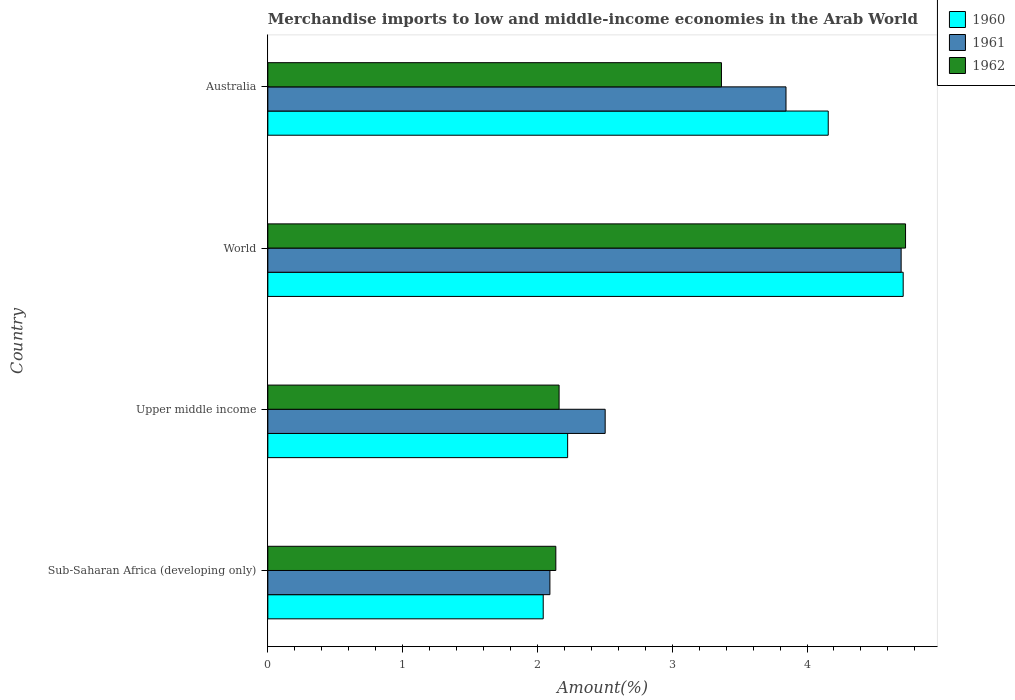How many groups of bars are there?
Your answer should be compact. 4. Are the number of bars per tick equal to the number of legend labels?
Give a very brief answer. Yes. How many bars are there on the 1st tick from the top?
Your response must be concise. 3. What is the label of the 1st group of bars from the top?
Offer a terse response. Australia. What is the percentage of amount earned from merchandise imports in 1962 in Upper middle income?
Your answer should be very brief. 2.16. Across all countries, what is the maximum percentage of amount earned from merchandise imports in 1961?
Your response must be concise. 4.7. Across all countries, what is the minimum percentage of amount earned from merchandise imports in 1961?
Make the answer very short. 2.09. In which country was the percentage of amount earned from merchandise imports in 1960 maximum?
Your answer should be compact. World. In which country was the percentage of amount earned from merchandise imports in 1962 minimum?
Offer a terse response. Sub-Saharan Africa (developing only). What is the total percentage of amount earned from merchandise imports in 1961 in the graph?
Offer a terse response. 13.14. What is the difference between the percentage of amount earned from merchandise imports in 1961 in Upper middle income and that in World?
Your response must be concise. -2.2. What is the difference between the percentage of amount earned from merchandise imports in 1960 in Upper middle income and the percentage of amount earned from merchandise imports in 1961 in Australia?
Keep it short and to the point. -1.62. What is the average percentage of amount earned from merchandise imports in 1962 per country?
Keep it short and to the point. 3.1. What is the difference between the percentage of amount earned from merchandise imports in 1961 and percentage of amount earned from merchandise imports in 1960 in World?
Offer a terse response. -0.02. What is the ratio of the percentage of amount earned from merchandise imports in 1960 in Upper middle income to that in World?
Keep it short and to the point. 0.47. Is the difference between the percentage of amount earned from merchandise imports in 1961 in Australia and World greater than the difference between the percentage of amount earned from merchandise imports in 1960 in Australia and World?
Keep it short and to the point. No. What is the difference between the highest and the second highest percentage of amount earned from merchandise imports in 1961?
Ensure brevity in your answer.  0.85. What is the difference between the highest and the lowest percentage of amount earned from merchandise imports in 1962?
Your answer should be compact. 2.59. Is the sum of the percentage of amount earned from merchandise imports in 1961 in Sub-Saharan Africa (developing only) and Upper middle income greater than the maximum percentage of amount earned from merchandise imports in 1960 across all countries?
Offer a very short reply. No. What does the 2nd bar from the bottom in Upper middle income represents?
Provide a short and direct response. 1961. How many bars are there?
Ensure brevity in your answer.  12. Are all the bars in the graph horizontal?
Give a very brief answer. Yes. How many countries are there in the graph?
Give a very brief answer. 4. Does the graph contain grids?
Keep it short and to the point. No. Where does the legend appear in the graph?
Keep it short and to the point. Top right. What is the title of the graph?
Offer a terse response. Merchandise imports to low and middle-income economies in the Arab World. What is the label or title of the X-axis?
Your answer should be very brief. Amount(%). What is the label or title of the Y-axis?
Provide a succinct answer. Country. What is the Amount(%) in 1960 in Sub-Saharan Africa (developing only)?
Your answer should be very brief. 2.04. What is the Amount(%) in 1961 in Sub-Saharan Africa (developing only)?
Provide a succinct answer. 2.09. What is the Amount(%) of 1962 in Sub-Saharan Africa (developing only)?
Provide a succinct answer. 2.14. What is the Amount(%) in 1960 in Upper middle income?
Your answer should be very brief. 2.22. What is the Amount(%) in 1961 in Upper middle income?
Your response must be concise. 2.5. What is the Amount(%) in 1962 in Upper middle income?
Offer a very short reply. 2.16. What is the Amount(%) in 1960 in World?
Provide a short and direct response. 4.71. What is the Amount(%) in 1961 in World?
Your answer should be compact. 4.7. What is the Amount(%) of 1962 in World?
Offer a very short reply. 4.73. What is the Amount(%) of 1960 in Australia?
Provide a succinct answer. 4.16. What is the Amount(%) in 1961 in Australia?
Make the answer very short. 3.84. What is the Amount(%) of 1962 in Australia?
Provide a succinct answer. 3.37. Across all countries, what is the maximum Amount(%) in 1960?
Your answer should be compact. 4.71. Across all countries, what is the maximum Amount(%) in 1961?
Offer a terse response. 4.7. Across all countries, what is the maximum Amount(%) in 1962?
Your response must be concise. 4.73. Across all countries, what is the minimum Amount(%) of 1960?
Your answer should be very brief. 2.04. Across all countries, what is the minimum Amount(%) of 1961?
Ensure brevity in your answer.  2.09. Across all countries, what is the minimum Amount(%) of 1962?
Provide a short and direct response. 2.14. What is the total Amount(%) in 1960 in the graph?
Keep it short and to the point. 13.14. What is the total Amount(%) of 1961 in the graph?
Ensure brevity in your answer.  13.14. What is the total Amount(%) in 1962 in the graph?
Your answer should be very brief. 12.39. What is the difference between the Amount(%) of 1960 in Sub-Saharan Africa (developing only) and that in Upper middle income?
Your response must be concise. -0.18. What is the difference between the Amount(%) of 1961 in Sub-Saharan Africa (developing only) and that in Upper middle income?
Offer a very short reply. -0.41. What is the difference between the Amount(%) of 1962 in Sub-Saharan Africa (developing only) and that in Upper middle income?
Your answer should be compact. -0.02. What is the difference between the Amount(%) of 1960 in Sub-Saharan Africa (developing only) and that in World?
Keep it short and to the point. -2.67. What is the difference between the Amount(%) of 1961 in Sub-Saharan Africa (developing only) and that in World?
Give a very brief answer. -2.61. What is the difference between the Amount(%) in 1962 in Sub-Saharan Africa (developing only) and that in World?
Your answer should be very brief. -2.59. What is the difference between the Amount(%) in 1960 in Sub-Saharan Africa (developing only) and that in Australia?
Offer a terse response. -2.11. What is the difference between the Amount(%) in 1961 in Sub-Saharan Africa (developing only) and that in Australia?
Keep it short and to the point. -1.75. What is the difference between the Amount(%) of 1962 in Sub-Saharan Africa (developing only) and that in Australia?
Ensure brevity in your answer.  -1.23. What is the difference between the Amount(%) in 1960 in Upper middle income and that in World?
Offer a very short reply. -2.49. What is the difference between the Amount(%) in 1961 in Upper middle income and that in World?
Make the answer very short. -2.2. What is the difference between the Amount(%) in 1962 in Upper middle income and that in World?
Provide a succinct answer. -2.57. What is the difference between the Amount(%) in 1960 in Upper middle income and that in Australia?
Give a very brief answer. -1.93. What is the difference between the Amount(%) in 1961 in Upper middle income and that in Australia?
Your answer should be compact. -1.34. What is the difference between the Amount(%) in 1962 in Upper middle income and that in Australia?
Make the answer very short. -1.2. What is the difference between the Amount(%) in 1960 in World and that in Australia?
Ensure brevity in your answer.  0.56. What is the difference between the Amount(%) in 1961 in World and that in Australia?
Offer a very short reply. 0.85. What is the difference between the Amount(%) of 1962 in World and that in Australia?
Offer a terse response. 1.37. What is the difference between the Amount(%) in 1960 in Sub-Saharan Africa (developing only) and the Amount(%) in 1961 in Upper middle income?
Your response must be concise. -0.46. What is the difference between the Amount(%) in 1960 in Sub-Saharan Africa (developing only) and the Amount(%) in 1962 in Upper middle income?
Provide a short and direct response. -0.12. What is the difference between the Amount(%) in 1961 in Sub-Saharan Africa (developing only) and the Amount(%) in 1962 in Upper middle income?
Offer a terse response. -0.07. What is the difference between the Amount(%) of 1960 in Sub-Saharan Africa (developing only) and the Amount(%) of 1961 in World?
Offer a very short reply. -2.66. What is the difference between the Amount(%) in 1960 in Sub-Saharan Africa (developing only) and the Amount(%) in 1962 in World?
Your answer should be compact. -2.69. What is the difference between the Amount(%) of 1961 in Sub-Saharan Africa (developing only) and the Amount(%) of 1962 in World?
Provide a short and direct response. -2.64. What is the difference between the Amount(%) of 1960 in Sub-Saharan Africa (developing only) and the Amount(%) of 1961 in Australia?
Make the answer very short. -1.8. What is the difference between the Amount(%) in 1960 in Sub-Saharan Africa (developing only) and the Amount(%) in 1962 in Australia?
Your answer should be very brief. -1.32. What is the difference between the Amount(%) in 1961 in Sub-Saharan Africa (developing only) and the Amount(%) in 1962 in Australia?
Make the answer very short. -1.27. What is the difference between the Amount(%) of 1960 in Upper middle income and the Amount(%) of 1961 in World?
Provide a short and direct response. -2.47. What is the difference between the Amount(%) of 1960 in Upper middle income and the Amount(%) of 1962 in World?
Ensure brevity in your answer.  -2.51. What is the difference between the Amount(%) in 1961 in Upper middle income and the Amount(%) in 1962 in World?
Keep it short and to the point. -2.23. What is the difference between the Amount(%) of 1960 in Upper middle income and the Amount(%) of 1961 in Australia?
Give a very brief answer. -1.62. What is the difference between the Amount(%) in 1960 in Upper middle income and the Amount(%) in 1962 in Australia?
Give a very brief answer. -1.14. What is the difference between the Amount(%) in 1961 in Upper middle income and the Amount(%) in 1962 in Australia?
Keep it short and to the point. -0.86. What is the difference between the Amount(%) of 1960 in World and the Amount(%) of 1961 in Australia?
Offer a terse response. 0.87. What is the difference between the Amount(%) in 1960 in World and the Amount(%) in 1962 in Australia?
Your answer should be very brief. 1.35. What is the difference between the Amount(%) of 1961 in World and the Amount(%) of 1962 in Australia?
Ensure brevity in your answer.  1.33. What is the average Amount(%) in 1960 per country?
Provide a short and direct response. 3.28. What is the average Amount(%) of 1961 per country?
Make the answer very short. 3.28. What is the average Amount(%) in 1962 per country?
Ensure brevity in your answer.  3.1. What is the difference between the Amount(%) in 1960 and Amount(%) in 1961 in Sub-Saharan Africa (developing only)?
Give a very brief answer. -0.05. What is the difference between the Amount(%) in 1960 and Amount(%) in 1962 in Sub-Saharan Africa (developing only)?
Offer a terse response. -0.09. What is the difference between the Amount(%) of 1961 and Amount(%) of 1962 in Sub-Saharan Africa (developing only)?
Give a very brief answer. -0.04. What is the difference between the Amount(%) in 1960 and Amount(%) in 1961 in Upper middle income?
Provide a succinct answer. -0.28. What is the difference between the Amount(%) in 1960 and Amount(%) in 1962 in Upper middle income?
Your answer should be very brief. 0.06. What is the difference between the Amount(%) in 1961 and Amount(%) in 1962 in Upper middle income?
Your answer should be compact. 0.34. What is the difference between the Amount(%) in 1960 and Amount(%) in 1961 in World?
Keep it short and to the point. 0.02. What is the difference between the Amount(%) in 1960 and Amount(%) in 1962 in World?
Your answer should be compact. -0.02. What is the difference between the Amount(%) in 1961 and Amount(%) in 1962 in World?
Give a very brief answer. -0.03. What is the difference between the Amount(%) of 1960 and Amount(%) of 1961 in Australia?
Give a very brief answer. 0.31. What is the difference between the Amount(%) in 1960 and Amount(%) in 1962 in Australia?
Offer a very short reply. 0.79. What is the difference between the Amount(%) in 1961 and Amount(%) in 1962 in Australia?
Provide a short and direct response. 0.48. What is the ratio of the Amount(%) of 1960 in Sub-Saharan Africa (developing only) to that in Upper middle income?
Make the answer very short. 0.92. What is the ratio of the Amount(%) of 1961 in Sub-Saharan Africa (developing only) to that in Upper middle income?
Provide a succinct answer. 0.84. What is the ratio of the Amount(%) in 1962 in Sub-Saharan Africa (developing only) to that in Upper middle income?
Provide a succinct answer. 0.99. What is the ratio of the Amount(%) in 1960 in Sub-Saharan Africa (developing only) to that in World?
Your response must be concise. 0.43. What is the ratio of the Amount(%) of 1961 in Sub-Saharan Africa (developing only) to that in World?
Your answer should be compact. 0.45. What is the ratio of the Amount(%) in 1962 in Sub-Saharan Africa (developing only) to that in World?
Make the answer very short. 0.45. What is the ratio of the Amount(%) in 1960 in Sub-Saharan Africa (developing only) to that in Australia?
Offer a terse response. 0.49. What is the ratio of the Amount(%) in 1961 in Sub-Saharan Africa (developing only) to that in Australia?
Your answer should be compact. 0.54. What is the ratio of the Amount(%) of 1962 in Sub-Saharan Africa (developing only) to that in Australia?
Make the answer very short. 0.63. What is the ratio of the Amount(%) in 1960 in Upper middle income to that in World?
Your answer should be compact. 0.47. What is the ratio of the Amount(%) of 1961 in Upper middle income to that in World?
Your answer should be very brief. 0.53. What is the ratio of the Amount(%) in 1962 in Upper middle income to that in World?
Your response must be concise. 0.46. What is the ratio of the Amount(%) in 1960 in Upper middle income to that in Australia?
Make the answer very short. 0.54. What is the ratio of the Amount(%) in 1961 in Upper middle income to that in Australia?
Provide a short and direct response. 0.65. What is the ratio of the Amount(%) of 1962 in Upper middle income to that in Australia?
Your response must be concise. 0.64. What is the ratio of the Amount(%) in 1960 in World to that in Australia?
Make the answer very short. 1.13. What is the ratio of the Amount(%) in 1961 in World to that in Australia?
Give a very brief answer. 1.22. What is the ratio of the Amount(%) in 1962 in World to that in Australia?
Provide a succinct answer. 1.41. What is the difference between the highest and the second highest Amount(%) in 1960?
Provide a succinct answer. 0.56. What is the difference between the highest and the second highest Amount(%) of 1961?
Give a very brief answer. 0.85. What is the difference between the highest and the second highest Amount(%) in 1962?
Offer a terse response. 1.37. What is the difference between the highest and the lowest Amount(%) in 1960?
Provide a succinct answer. 2.67. What is the difference between the highest and the lowest Amount(%) of 1961?
Ensure brevity in your answer.  2.61. What is the difference between the highest and the lowest Amount(%) of 1962?
Your response must be concise. 2.59. 